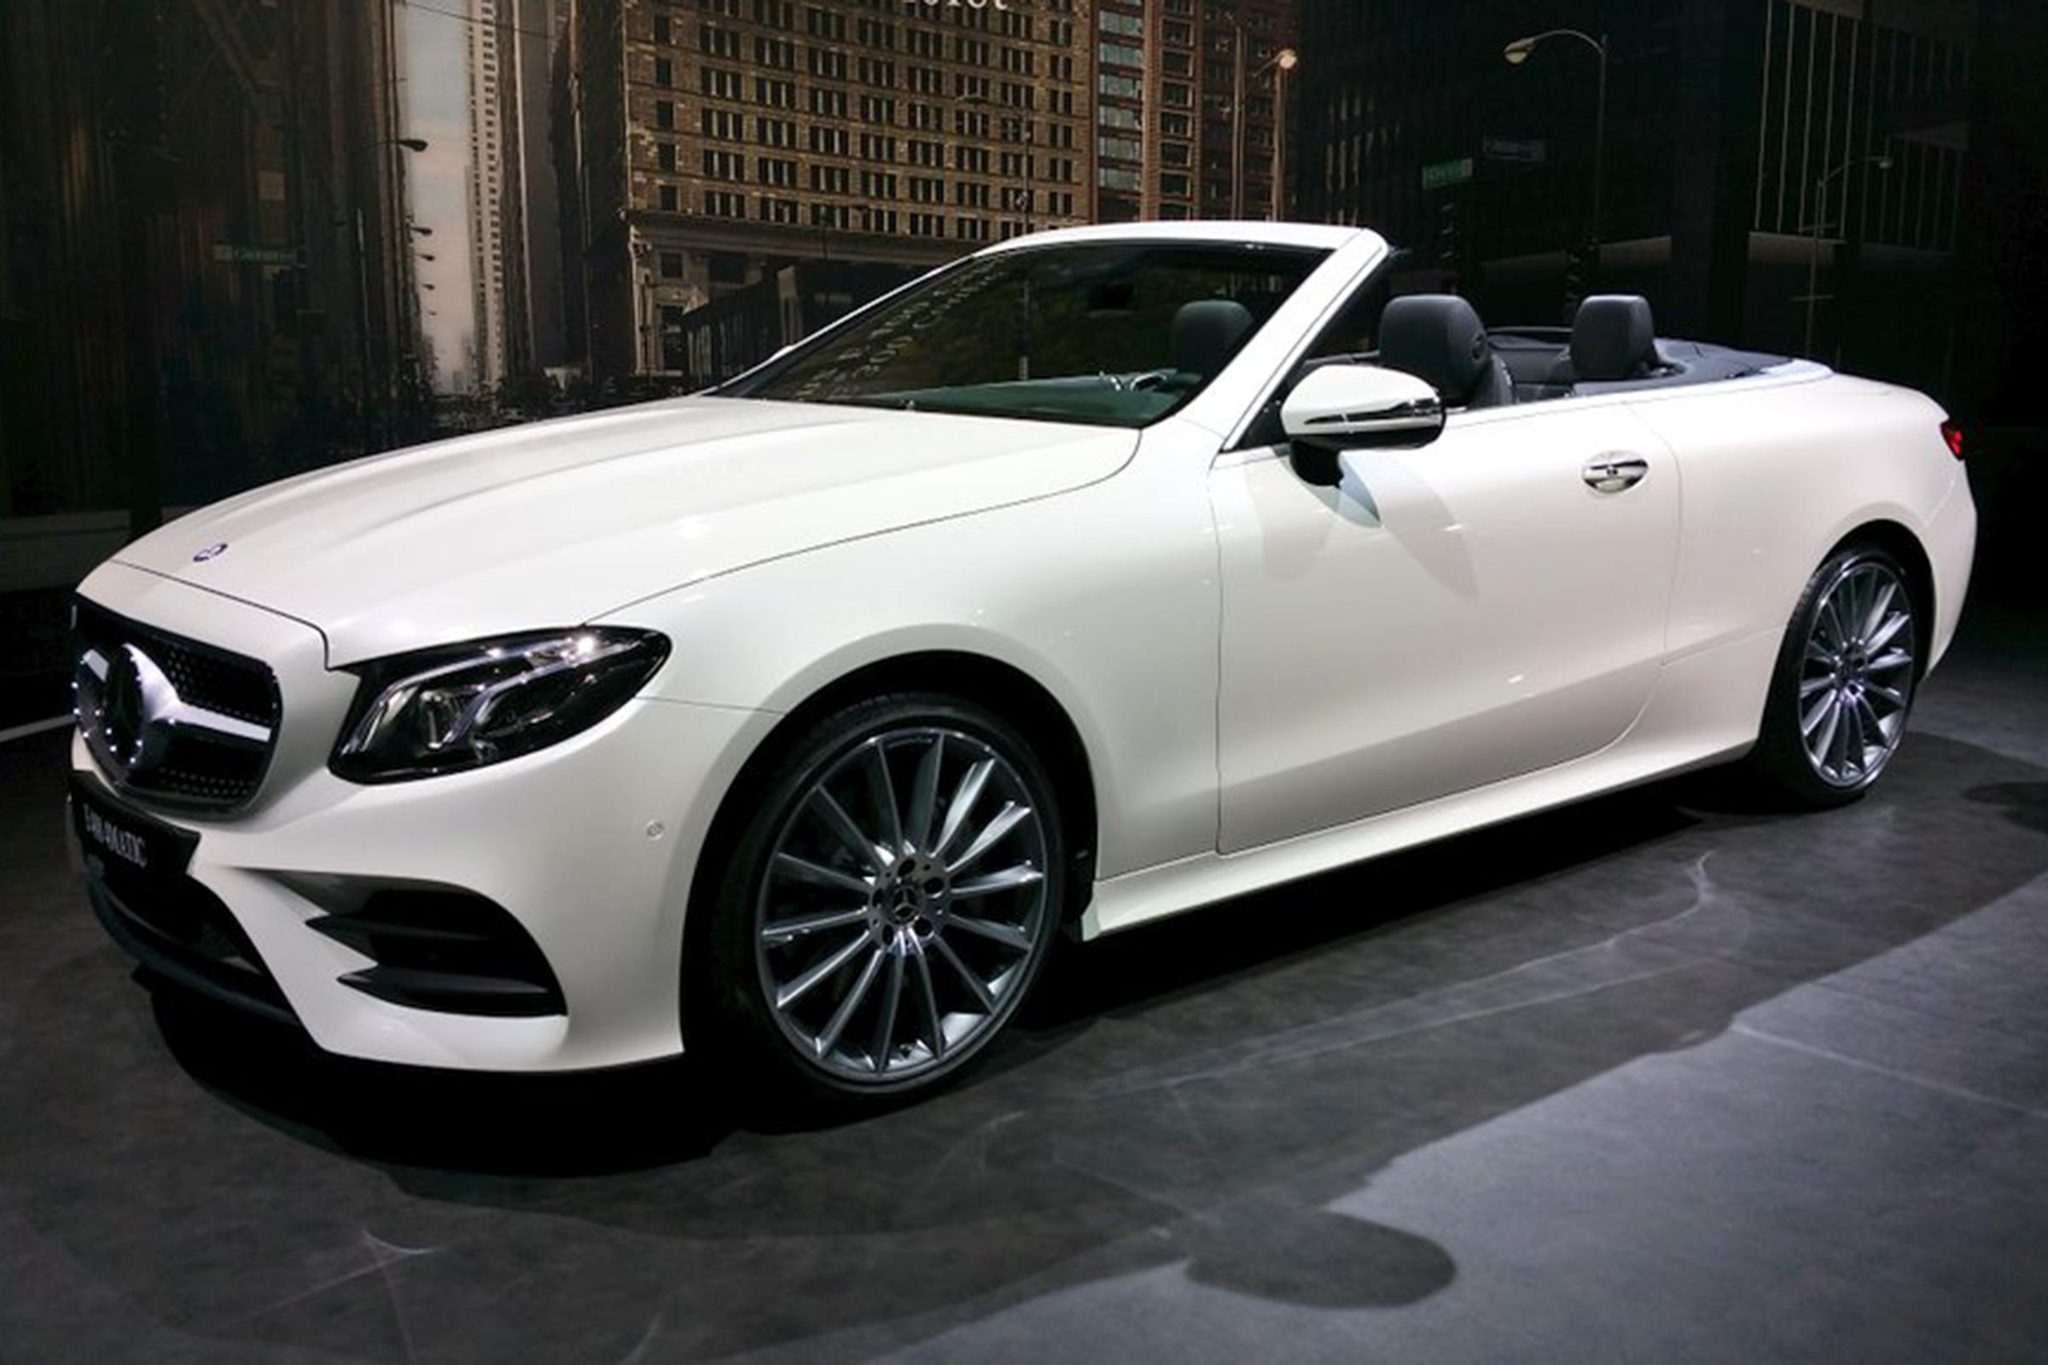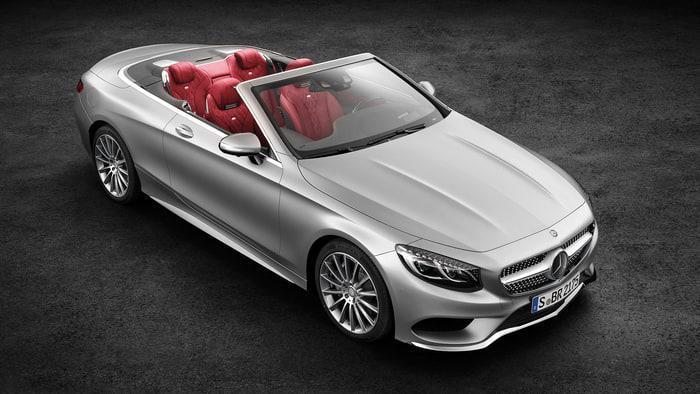The first image is the image on the left, the second image is the image on the right. For the images shown, is this caption "One image shows a white convertible with its top covered." true? Answer yes or no. No. The first image is the image on the left, the second image is the image on the right. Analyze the images presented: Is the assertion "In one of the images there is a convertible parked outside with a building visible in the background." valid? Answer yes or no. Yes. 